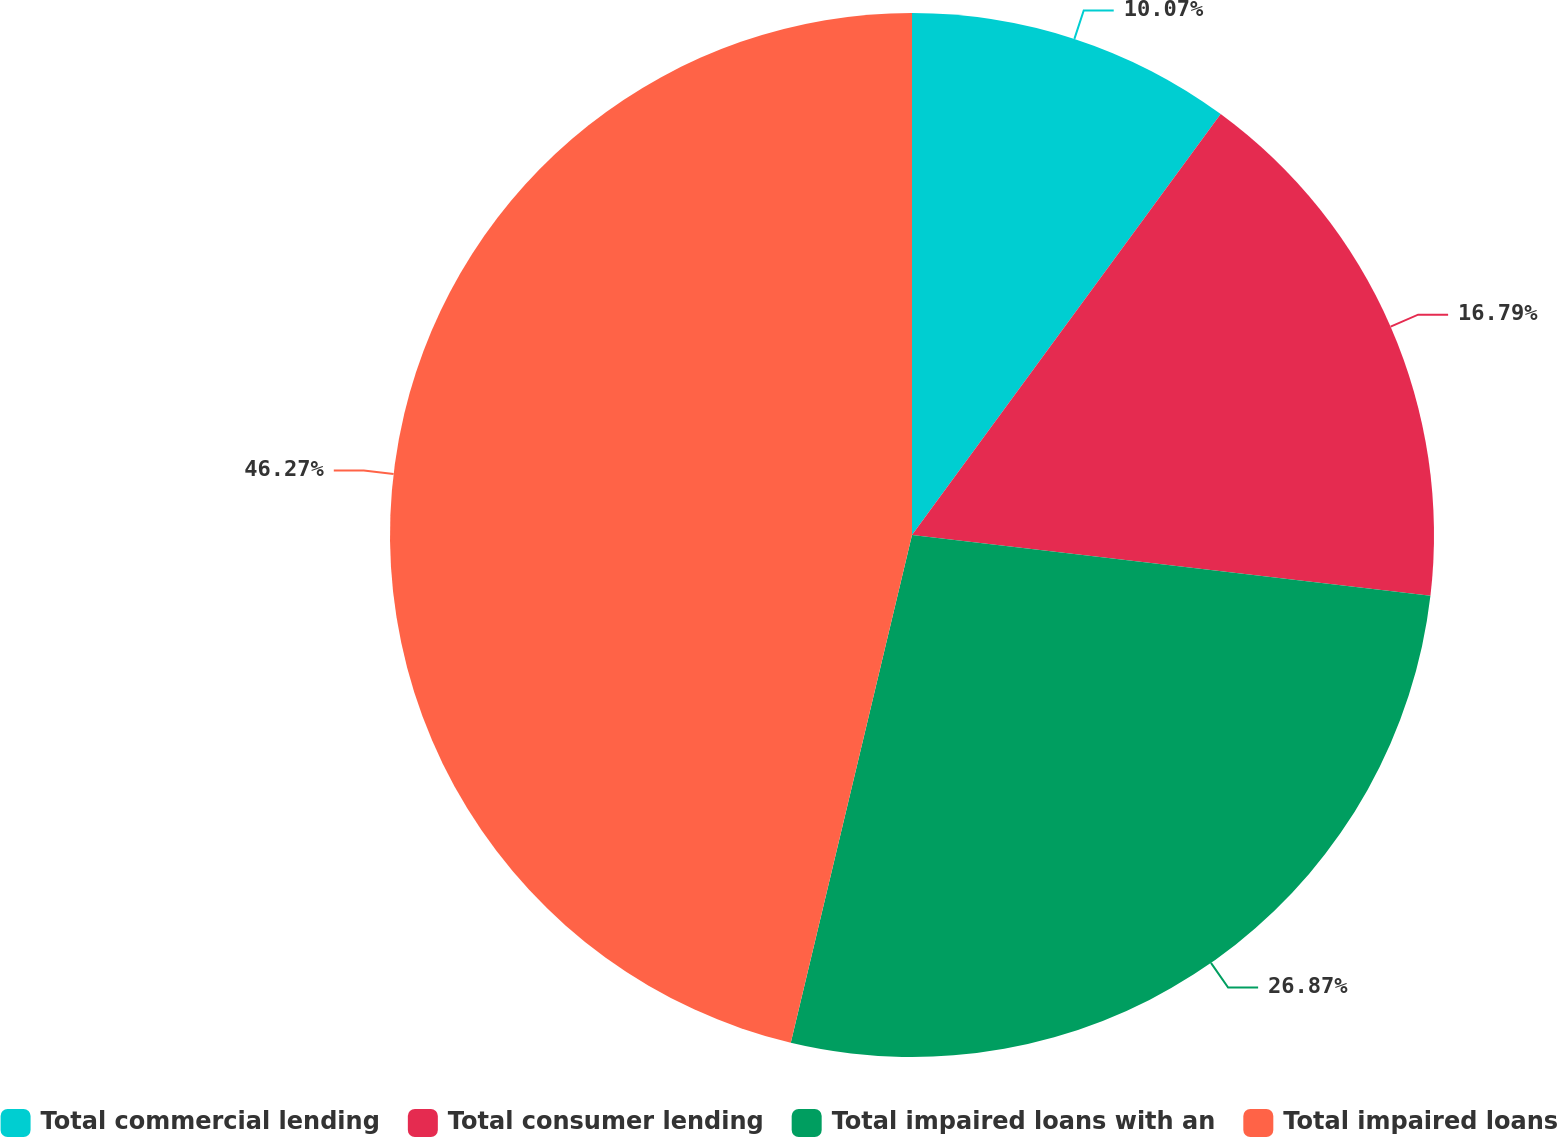<chart> <loc_0><loc_0><loc_500><loc_500><pie_chart><fcel>Total commercial lending<fcel>Total consumer lending<fcel>Total impaired loans with an<fcel>Total impaired loans<nl><fcel>10.07%<fcel>16.79%<fcel>26.87%<fcel>46.27%<nl></chart> 